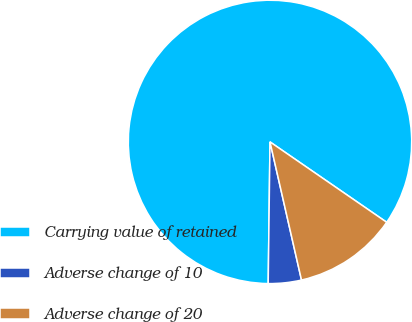<chart> <loc_0><loc_0><loc_500><loc_500><pie_chart><fcel>Carrying value of retained<fcel>Adverse change of 10<fcel>Adverse change of 20<nl><fcel>84.39%<fcel>3.77%<fcel>11.83%<nl></chart> 